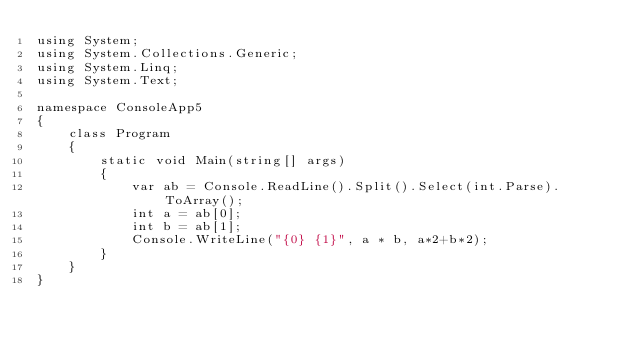<code> <loc_0><loc_0><loc_500><loc_500><_C#_>using System;
using System.Collections.Generic;
using System.Linq;
using System.Text;

namespace ConsoleApp5
{
    class Program
    {
        static void Main(string[] args)
        {
            var ab = Console.ReadLine().Split().Select(int.Parse).ToArray();
            int a = ab[0];
            int b = ab[1];
            Console.WriteLine("{0} {1}", a * b, a*2+b*2);
        }
    }
}</code> 